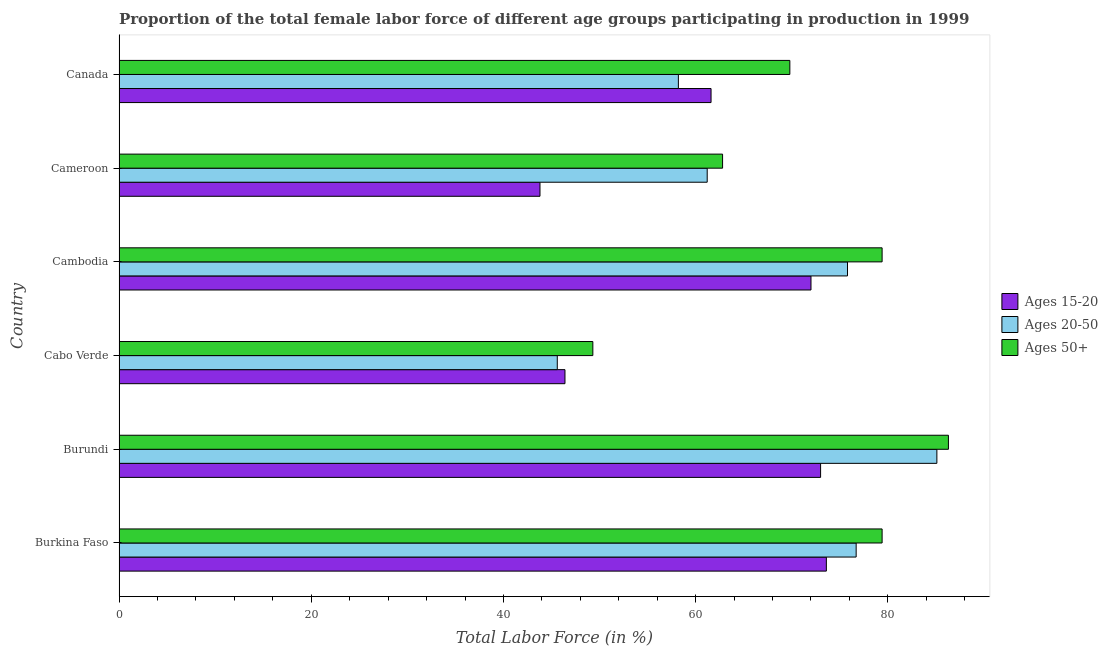How many groups of bars are there?
Offer a very short reply. 6. Are the number of bars per tick equal to the number of legend labels?
Offer a very short reply. Yes. How many bars are there on the 6th tick from the top?
Give a very brief answer. 3. How many bars are there on the 2nd tick from the bottom?
Make the answer very short. 3. What is the label of the 4th group of bars from the top?
Keep it short and to the point. Cabo Verde. In how many cases, is the number of bars for a given country not equal to the number of legend labels?
Your response must be concise. 0. What is the percentage of female labor force above age 50 in Cameroon?
Your answer should be compact. 62.8. Across all countries, what is the maximum percentage of female labor force within the age group 15-20?
Make the answer very short. 73.6. Across all countries, what is the minimum percentage of female labor force within the age group 15-20?
Ensure brevity in your answer.  43.8. In which country was the percentage of female labor force above age 50 maximum?
Provide a succinct answer. Burundi. In which country was the percentage of female labor force above age 50 minimum?
Offer a very short reply. Cabo Verde. What is the total percentage of female labor force within the age group 15-20 in the graph?
Ensure brevity in your answer.  370.4. What is the difference between the percentage of female labor force above age 50 in Burkina Faso and that in Burundi?
Give a very brief answer. -6.9. What is the difference between the percentage of female labor force within the age group 20-50 in Canada and the percentage of female labor force within the age group 15-20 in Burkina Faso?
Your response must be concise. -15.4. What is the average percentage of female labor force within the age group 20-50 per country?
Your answer should be compact. 67.1. What is the ratio of the percentage of female labor force within the age group 15-20 in Burkina Faso to that in Cabo Verde?
Offer a very short reply. 1.59. Is the difference between the percentage of female labor force within the age group 15-20 in Cameroon and Canada greater than the difference between the percentage of female labor force within the age group 20-50 in Cameroon and Canada?
Give a very brief answer. No. What is the difference between the highest and the lowest percentage of female labor force within the age group 20-50?
Your answer should be very brief. 39.5. In how many countries, is the percentage of female labor force within the age group 20-50 greater than the average percentage of female labor force within the age group 20-50 taken over all countries?
Offer a terse response. 3. Is the sum of the percentage of female labor force above age 50 in Cabo Verde and Cameroon greater than the maximum percentage of female labor force within the age group 20-50 across all countries?
Your answer should be very brief. Yes. What does the 3rd bar from the top in Canada represents?
Provide a succinct answer. Ages 15-20. What does the 2nd bar from the bottom in Burkina Faso represents?
Give a very brief answer. Ages 20-50. Is it the case that in every country, the sum of the percentage of female labor force within the age group 15-20 and percentage of female labor force within the age group 20-50 is greater than the percentage of female labor force above age 50?
Your answer should be very brief. Yes. Are all the bars in the graph horizontal?
Give a very brief answer. Yes. What is the difference between two consecutive major ticks on the X-axis?
Ensure brevity in your answer.  20. Does the graph contain any zero values?
Offer a very short reply. No. Does the graph contain grids?
Your answer should be very brief. No. Where does the legend appear in the graph?
Your response must be concise. Center right. How many legend labels are there?
Make the answer very short. 3. What is the title of the graph?
Offer a very short reply. Proportion of the total female labor force of different age groups participating in production in 1999. What is the label or title of the X-axis?
Offer a very short reply. Total Labor Force (in %). What is the label or title of the Y-axis?
Make the answer very short. Country. What is the Total Labor Force (in %) in Ages 15-20 in Burkina Faso?
Offer a terse response. 73.6. What is the Total Labor Force (in %) in Ages 20-50 in Burkina Faso?
Provide a succinct answer. 76.7. What is the Total Labor Force (in %) in Ages 50+ in Burkina Faso?
Offer a terse response. 79.4. What is the Total Labor Force (in %) in Ages 20-50 in Burundi?
Give a very brief answer. 85.1. What is the Total Labor Force (in %) in Ages 50+ in Burundi?
Keep it short and to the point. 86.3. What is the Total Labor Force (in %) in Ages 15-20 in Cabo Verde?
Make the answer very short. 46.4. What is the Total Labor Force (in %) in Ages 20-50 in Cabo Verde?
Provide a short and direct response. 45.6. What is the Total Labor Force (in %) in Ages 50+ in Cabo Verde?
Offer a terse response. 49.3. What is the Total Labor Force (in %) in Ages 15-20 in Cambodia?
Give a very brief answer. 72. What is the Total Labor Force (in %) in Ages 20-50 in Cambodia?
Keep it short and to the point. 75.8. What is the Total Labor Force (in %) in Ages 50+ in Cambodia?
Ensure brevity in your answer.  79.4. What is the Total Labor Force (in %) of Ages 15-20 in Cameroon?
Your answer should be compact. 43.8. What is the Total Labor Force (in %) of Ages 20-50 in Cameroon?
Your answer should be compact. 61.2. What is the Total Labor Force (in %) of Ages 50+ in Cameroon?
Provide a succinct answer. 62.8. What is the Total Labor Force (in %) in Ages 15-20 in Canada?
Offer a terse response. 61.6. What is the Total Labor Force (in %) in Ages 20-50 in Canada?
Offer a very short reply. 58.2. What is the Total Labor Force (in %) in Ages 50+ in Canada?
Your answer should be compact. 69.8. Across all countries, what is the maximum Total Labor Force (in %) of Ages 15-20?
Your response must be concise. 73.6. Across all countries, what is the maximum Total Labor Force (in %) in Ages 20-50?
Keep it short and to the point. 85.1. Across all countries, what is the maximum Total Labor Force (in %) of Ages 50+?
Your answer should be very brief. 86.3. Across all countries, what is the minimum Total Labor Force (in %) in Ages 15-20?
Give a very brief answer. 43.8. Across all countries, what is the minimum Total Labor Force (in %) in Ages 20-50?
Your answer should be compact. 45.6. Across all countries, what is the minimum Total Labor Force (in %) in Ages 50+?
Provide a short and direct response. 49.3. What is the total Total Labor Force (in %) of Ages 15-20 in the graph?
Your answer should be compact. 370.4. What is the total Total Labor Force (in %) of Ages 20-50 in the graph?
Provide a succinct answer. 402.6. What is the total Total Labor Force (in %) in Ages 50+ in the graph?
Your response must be concise. 427. What is the difference between the Total Labor Force (in %) of Ages 15-20 in Burkina Faso and that in Cabo Verde?
Give a very brief answer. 27.2. What is the difference between the Total Labor Force (in %) in Ages 20-50 in Burkina Faso and that in Cabo Verde?
Ensure brevity in your answer.  31.1. What is the difference between the Total Labor Force (in %) of Ages 50+ in Burkina Faso and that in Cabo Verde?
Ensure brevity in your answer.  30.1. What is the difference between the Total Labor Force (in %) of Ages 15-20 in Burkina Faso and that in Cambodia?
Give a very brief answer. 1.6. What is the difference between the Total Labor Force (in %) in Ages 20-50 in Burkina Faso and that in Cambodia?
Keep it short and to the point. 0.9. What is the difference between the Total Labor Force (in %) of Ages 15-20 in Burkina Faso and that in Cameroon?
Provide a succinct answer. 29.8. What is the difference between the Total Labor Force (in %) of Ages 20-50 in Burkina Faso and that in Canada?
Your answer should be very brief. 18.5. What is the difference between the Total Labor Force (in %) of Ages 50+ in Burkina Faso and that in Canada?
Your response must be concise. 9.6. What is the difference between the Total Labor Force (in %) in Ages 15-20 in Burundi and that in Cabo Verde?
Make the answer very short. 26.6. What is the difference between the Total Labor Force (in %) in Ages 20-50 in Burundi and that in Cabo Verde?
Offer a terse response. 39.5. What is the difference between the Total Labor Force (in %) of Ages 50+ in Burundi and that in Cabo Verde?
Keep it short and to the point. 37. What is the difference between the Total Labor Force (in %) in Ages 15-20 in Burundi and that in Cambodia?
Keep it short and to the point. 1. What is the difference between the Total Labor Force (in %) of Ages 15-20 in Burundi and that in Cameroon?
Provide a succinct answer. 29.2. What is the difference between the Total Labor Force (in %) of Ages 20-50 in Burundi and that in Cameroon?
Make the answer very short. 23.9. What is the difference between the Total Labor Force (in %) of Ages 20-50 in Burundi and that in Canada?
Keep it short and to the point. 26.9. What is the difference between the Total Labor Force (in %) of Ages 15-20 in Cabo Verde and that in Cambodia?
Provide a succinct answer. -25.6. What is the difference between the Total Labor Force (in %) of Ages 20-50 in Cabo Verde and that in Cambodia?
Your response must be concise. -30.2. What is the difference between the Total Labor Force (in %) in Ages 50+ in Cabo Verde and that in Cambodia?
Provide a short and direct response. -30.1. What is the difference between the Total Labor Force (in %) of Ages 20-50 in Cabo Verde and that in Cameroon?
Provide a succinct answer. -15.6. What is the difference between the Total Labor Force (in %) in Ages 15-20 in Cabo Verde and that in Canada?
Keep it short and to the point. -15.2. What is the difference between the Total Labor Force (in %) in Ages 20-50 in Cabo Verde and that in Canada?
Give a very brief answer. -12.6. What is the difference between the Total Labor Force (in %) of Ages 50+ in Cabo Verde and that in Canada?
Offer a very short reply. -20.5. What is the difference between the Total Labor Force (in %) of Ages 15-20 in Cambodia and that in Cameroon?
Provide a succinct answer. 28.2. What is the difference between the Total Labor Force (in %) of Ages 20-50 in Cambodia and that in Cameroon?
Your answer should be very brief. 14.6. What is the difference between the Total Labor Force (in %) in Ages 50+ in Cambodia and that in Cameroon?
Offer a terse response. 16.6. What is the difference between the Total Labor Force (in %) of Ages 50+ in Cambodia and that in Canada?
Provide a succinct answer. 9.6. What is the difference between the Total Labor Force (in %) in Ages 15-20 in Cameroon and that in Canada?
Make the answer very short. -17.8. What is the difference between the Total Labor Force (in %) in Ages 20-50 in Cameroon and that in Canada?
Give a very brief answer. 3. What is the difference between the Total Labor Force (in %) in Ages 50+ in Cameroon and that in Canada?
Ensure brevity in your answer.  -7. What is the difference between the Total Labor Force (in %) of Ages 15-20 in Burkina Faso and the Total Labor Force (in %) of Ages 20-50 in Burundi?
Provide a short and direct response. -11.5. What is the difference between the Total Labor Force (in %) in Ages 15-20 in Burkina Faso and the Total Labor Force (in %) in Ages 50+ in Cabo Verde?
Offer a very short reply. 24.3. What is the difference between the Total Labor Force (in %) in Ages 20-50 in Burkina Faso and the Total Labor Force (in %) in Ages 50+ in Cabo Verde?
Offer a terse response. 27.4. What is the difference between the Total Labor Force (in %) of Ages 15-20 in Burkina Faso and the Total Labor Force (in %) of Ages 20-50 in Cambodia?
Keep it short and to the point. -2.2. What is the difference between the Total Labor Force (in %) of Ages 15-20 in Burkina Faso and the Total Labor Force (in %) of Ages 50+ in Cambodia?
Make the answer very short. -5.8. What is the difference between the Total Labor Force (in %) of Ages 20-50 in Burkina Faso and the Total Labor Force (in %) of Ages 50+ in Cambodia?
Your answer should be very brief. -2.7. What is the difference between the Total Labor Force (in %) in Ages 15-20 in Burkina Faso and the Total Labor Force (in %) in Ages 20-50 in Cameroon?
Offer a terse response. 12.4. What is the difference between the Total Labor Force (in %) of Ages 20-50 in Burkina Faso and the Total Labor Force (in %) of Ages 50+ in Cameroon?
Your response must be concise. 13.9. What is the difference between the Total Labor Force (in %) in Ages 15-20 in Burkina Faso and the Total Labor Force (in %) in Ages 20-50 in Canada?
Ensure brevity in your answer.  15.4. What is the difference between the Total Labor Force (in %) in Ages 15-20 in Burundi and the Total Labor Force (in %) in Ages 20-50 in Cabo Verde?
Give a very brief answer. 27.4. What is the difference between the Total Labor Force (in %) in Ages 15-20 in Burundi and the Total Labor Force (in %) in Ages 50+ in Cabo Verde?
Keep it short and to the point. 23.7. What is the difference between the Total Labor Force (in %) in Ages 20-50 in Burundi and the Total Labor Force (in %) in Ages 50+ in Cabo Verde?
Give a very brief answer. 35.8. What is the difference between the Total Labor Force (in %) in Ages 15-20 in Burundi and the Total Labor Force (in %) in Ages 20-50 in Cameroon?
Your response must be concise. 11.8. What is the difference between the Total Labor Force (in %) of Ages 15-20 in Burundi and the Total Labor Force (in %) of Ages 50+ in Cameroon?
Provide a short and direct response. 10.2. What is the difference between the Total Labor Force (in %) in Ages 20-50 in Burundi and the Total Labor Force (in %) in Ages 50+ in Cameroon?
Your response must be concise. 22.3. What is the difference between the Total Labor Force (in %) in Ages 15-20 in Burundi and the Total Labor Force (in %) in Ages 20-50 in Canada?
Offer a very short reply. 14.8. What is the difference between the Total Labor Force (in %) of Ages 20-50 in Burundi and the Total Labor Force (in %) of Ages 50+ in Canada?
Keep it short and to the point. 15.3. What is the difference between the Total Labor Force (in %) in Ages 15-20 in Cabo Verde and the Total Labor Force (in %) in Ages 20-50 in Cambodia?
Keep it short and to the point. -29.4. What is the difference between the Total Labor Force (in %) of Ages 15-20 in Cabo Verde and the Total Labor Force (in %) of Ages 50+ in Cambodia?
Provide a succinct answer. -33. What is the difference between the Total Labor Force (in %) of Ages 20-50 in Cabo Verde and the Total Labor Force (in %) of Ages 50+ in Cambodia?
Provide a succinct answer. -33.8. What is the difference between the Total Labor Force (in %) of Ages 15-20 in Cabo Verde and the Total Labor Force (in %) of Ages 20-50 in Cameroon?
Make the answer very short. -14.8. What is the difference between the Total Labor Force (in %) of Ages 15-20 in Cabo Verde and the Total Labor Force (in %) of Ages 50+ in Cameroon?
Offer a very short reply. -16.4. What is the difference between the Total Labor Force (in %) in Ages 20-50 in Cabo Verde and the Total Labor Force (in %) in Ages 50+ in Cameroon?
Provide a succinct answer. -17.2. What is the difference between the Total Labor Force (in %) of Ages 15-20 in Cabo Verde and the Total Labor Force (in %) of Ages 50+ in Canada?
Provide a short and direct response. -23.4. What is the difference between the Total Labor Force (in %) of Ages 20-50 in Cabo Verde and the Total Labor Force (in %) of Ages 50+ in Canada?
Your answer should be compact. -24.2. What is the difference between the Total Labor Force (in %) in Ages 15-20 in Cambodia and the Total Labor Force (in %) in Ages 50+ in Cameroon?
Provide a short and direct response. 9.2. What is the difference between the Total Labor Force (in %) of Ages 15-20 in Cambodia and the Total Labor Force (in %) of Ages 50+ in Canada?
Make the answer very short. 2.2. What is the difference between the Total Labor Force (in %) of Ages 20-50 in Cambodia and the Total Labor Force (in %) of Ages 50+ in Canada?
Your response must be concise. 6. What is the difference between the Total Labor Force (in %) of Ages 15-20 in Cameroon and the Total Labor Force (in %) of Ages 20-50 in Canada?
Your answer should be compact. -14.4. What is the average Total Labor Force (in %) of Ages 15-20 per country?
Ensure brevity in your answer.  61.73. What is the average Total Labor Force (in %) in Ages 20-50 per country?
Provide a succinct answer. 67.1. What is the average Total Labor Force (in %) in Ages 50+ per country?
Provide a short and direct response. 71.17. What is the difference between the Total Labor Force (in %) of Ages 15-20 and Total Labor Force (in %) of Ages 20-50 in Burkina Faso?
Offer a very short reply. -3.1. What is the difference between the Total Labor Force (in %) in Ages 15-20 and Total Labor Force (in %) in Ages 50+ in Burkina Faso?
Provide a succinct answer. -5.8. What is the difference between the Total Labor Force (in %) of Ages 20-50 and Total Labor Force (in %) of Ages 50+ in Burkina Faso?
Ensure brevity in your answer.  -2.7. What is the difference between the Total Labor Force (in %) of Ages 15-20 and Total Labor Force (in %) of Ages 20-50 in Burundi?
Your response must be concise. -12.1. What is the difference between the Total Labor Force (in %) of Ages 15-20 and Total Labor Force (in %) of Ages 50+ in Burundi?
Offer a terse response. -13.3. What is the difference between the Total Labor Force (in %) of Ages 15-20 and Total Labor Force (in %) of Ages 20-50 in Cabo Verde?
Ensure brevity in your answer.  0.8. What is the difference between the Total Labor Force (in %) in Ages 20-50 and Total Labor Force (in %) in Ages 50+ in Cabo Verde?
Your answer should be compact. -3.7. What is the difference between the Total Labor Force (in %) in Ages 15-20 and Total Labor Force (in %) in Ages 20-50 in Cambodia?
Your answer should be very brief. -3.8. What is the difference between the Total Labor Force (in %) in Ages 15-20 and Total Labor Force (in %) in Ages 50+ in Cambodia?
Provide a succinct answer. -7.4. What is the difference between the Total Labor Force (in %) of Ages 20-50 and Total Labor Force (in %) of Ages 50+ in Cambodia?
Keep it short and to the point. -3.6. What is the difference between the Total Labor Force (in %) of Ages 15-20 and Total Labor Force (in %) of Ages 20-50 in Cameroon?
Your answer should be very brief. -17.4. What is the difference between the Total Labor Force (in %) in Ages 20-50 and Total Labor Force (in %) in Ages 50+ in Cameroon?
Provide a short and direct response. -1.6. What is the difference between the Total Labor Force (in %) in Ages 20-50 and Total Labor Force (in %) in Ages 50+ in Canada?
Ensure brevity in your answer.  -11.6. What is the ratio of the Total Labor Force (in %) of Ages 15-20 in Burkina Faso to that in Burundi?
Keep it short and to the point. 1.01. What is the ratio of the Total Labor Force (in %) of Ages 20-50 in Burkina Faso to that in Burundi?
Offer a very short reply. 0.9. What is the ratio of the Total Labor Force (in %) of Ages 50+ in Burkina Faso to that in Burundi?
Give a very brief answer. 0.92. What is the ratio of the Total Labor Force (in %) of Ages 15-20 in Burkina Faso to that in Cabo Verde?
Offer a terse response. 1.59. What is the ratio of the Total Labor Force (in %) in Ages 20-50 in Burkina Faso to that in Cabo Verde?
Provide a succinct answer. 1.68. What is the ratio of the Total Labor Force (in %) of Ages 50+ in Burkina Faso to that in Cabo Verde?
Offer a terse response. 1.61. What is the ratio of the Total Labor Force (in %) of Ages 15-20 in Burkina Faso to that in Cambodia?
Give a very brief answer. 1.02. What is the ratio of the Total Labor Force (in %) in Ages 20-50 in Burkina Faso to that in Cambodia?
Ensure brevity in your answer.  1.01. What is the ratio of the Total Labor Force (in %) in Ages 50+ in Burkina Faso to that in Cambodia?
Provide a succinct answer. 1. What is the ratio of the Total Labor Force (in %) of Ages 15-20 in Burkina Faso to that in Cameroon?
Make the answer very short. 1.68. What is the ratio of the Total Labor Force (in %) of Ages 20-50 in Burkina Faso to that in Cameroon?
Your answer should be compact. 1.25. What is the ratio of the Total Labor Force (in %) in Ages 50+ in Burkina Faso to that in Cameroon?
Offer a very short reply. 1.26. What is the ratio of the Total Labor Force (in %) of Ages 15-20 in Burkina Faso to that in Canada?
Give a very brief answer. 1.19. What is the ratio of the Total Labor Force (in %) in Ages 20-50 in Burkina Faso to that in Canada?
Provide a succinct answer. 1.32. What is the ratio of the Total Labor Force (in %) of Ages 50+ in Burkina Faso to that in Canada?
Your answer should be very brief. 1.14. What is the ratio of the Total Labor Force (in %) of Ages 15-20 in Burundi to that in Cabo Verde?
Provide a succinct answer. 1.57. What is the ratio of the Total Labor Force (in %) of Ages 20-50 in Burundi to that in Cabo Verde?
Ensure brevity in your answer.  1.87. What is the ratio of the Total Labor Force (in %) of Ages 50+ in Burundi to that in Cabo Verde?
Your response must be concise. 1.75. What is the ratio of the Total Labor Force (in %) in Ages 15-20 in Burundi to that in Cambodia?
Offer a very short reply. 1.01. What is the ratio of the Total Labor Force (in %) in Ages 20-50 in Burundi to that in Cambodia?
Your answer should be compact. 1.12. What is the ratio of the Total Labor Force (in %) of Ages 50+ in Burundi to that in Cambodia?
Offer a very short reply. 1.09. What is the ratio of the Total Labor Force (in %) in Ages 20-50 in Burundi to that in Cameroon?
Your answer should be very brief. 1.39. What is the ratio of the Total Labor Force (in %) of Ages 50+ in Burundi to that in Cameroon?
Ensure brevity in your answer.  1.37. What is the ratio of the Total Labor Force (in %) of Ages 15-20 in Burundi to that in Canada?
Keep it short and to the point. 1.19. What is the ratio of the Total Labor Force (in %) in Ages 20-50 in Burundi to that in Canada?
Make the answer very short. 1.46. What is the ratio of the Total Labor Force (in %) in Ages 50+ in Burundi to that in Canada?
Your answer should be compact. 1.24. What is the ratio of the Total Labor Force (in %) of Ages 15-20 in Cabo Verde to that in Cambodia?
Your response must be concise. 0.64. What is the ratio of the Total Labor Force (in %) of Ages 20-50 in Cabo Verde to that in Cambodia?
Provide a short and direct response. 0.6. What is the ratio of the Total Labor Force (in %) in Ages 50+ in Cabo Verde to that in Cambodia?
Your answer should be very brief. 0.62. What is the ratio of the Total Labor Force (in %) of Ages 15-20 in Cabo Verde to that in Cameroon?
Offer a very short reply. 1.06. What is the ratio of the Total Labor Force (in %) of Ages 20-50 in Cabo Verde to that in Cameroon?
Provide a succinct answer. 0.75. What is the ratio of the Total Labor Force (in %) in Ages 50+ in Cabo Verde to that in Cameroon?
Offer a very short reply. 0.79. What is the ratio of the Total Labor Force (in %) of Ages 15-20 in Cabo Verde to that in Canada?
Your response must be concise. 0.75. What is the ratio of the Total Labor Force (in %) in Ages 20-50 in Cabo Verde to that in Canada?
Your answer should be very brief. 0.78. What is the ratio of the Total Labor Force (in %) of Ages 50+ in Cabo Verde to that in Canada?
Give a very brief answer. 0.71. What is the ratio of the Total Labor Force (in %) in Ages 15-20 in Cambodia to that in Cameroon?
Offer a very short reply. 1.64. What is the ratio of the Total Labor Force (in %) in Ages 20-50 in Cambodia to that in Cameroon?
Provide a succinct answer. 1.24. What is the ratio of the Total Labor Force (in %) in Ages 50+ in Cambodia to that in Cameroon?
Ensure brevity in your answer.  1.26. What is the ratio of the Total Labor Force (in %) in Ages 15-20 in Cambodia to that in Canada?
Provide a short and direct response. 1.17. What is the ratio of the Total Labor Force (in %) of Ages 20-50 in Cambodia to that in Canada?
Provide a succinct answer. 1.3. What is the ratio of the Total Labor Force (in %) of Ages 50+ in Cambodia to that in Canada?
Provide a short and direct response. 1.14. What is the ratio of the Total Labor Force (in %) of Ages 15-20 in Cameroon to that in Canada?
Provide a succinct answer. 0.71. What is the ratio of the Total Labor Force (in %) in Ages 20-50 in Cameroon to that in Canada?
Offer a terse response. 1.05. What is the ratio of the Total Labor Force (in %) in Ages 50+ in Cameroon to that in Canada?
Give a very brief answer. 0.9. What is the difference between the highest and the second highest Total Labor Force (in %) of Ages 15-20?
Give a very brief answer. 0.6. What is the difference between the highest and the second highest Total Labor Force (in %) in Ages 20-50?
Your answer should be compact. 8.4. What is the difference between the highest and the second highest Total Labor Force (in %) of Ages 50+?
Give a very brief answer. 6.9. What is the difference between the highest and the lowest Total Labor Force (in %) in Ages 15-20?
Ensure brevity in your answer.  29.8. What is the difference between the highest and the lowest Total Labor Force (in %) in Ages 20-50?
Offer a very short reply. 39.5. What is the difference between the highest and the lowest Total Labor Force (in %) of Ages 50+?
Your answer should be compact. 37. 